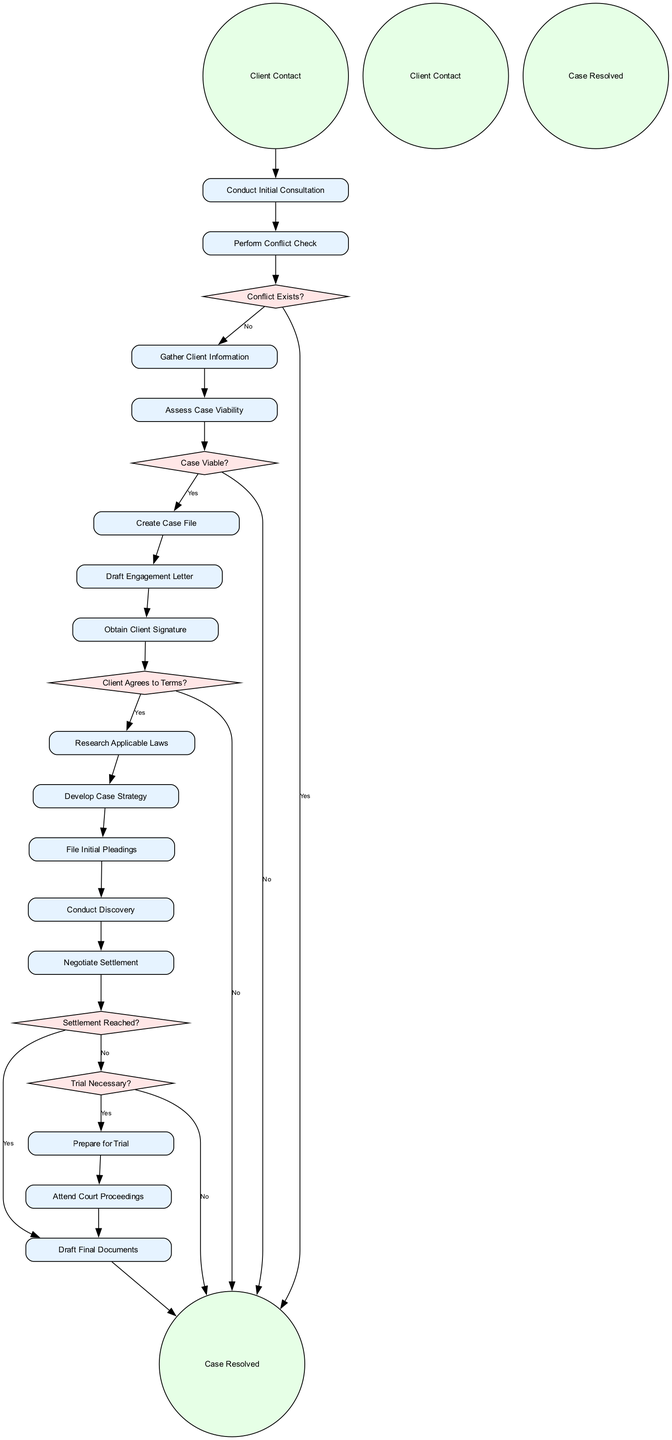What is the first activity in the process? The diagram starts with the initial node labeled "Client Contact," indicating this is the first step in the workflow.
Answer: Client Contact How many decision nodes are present in the diagram? The diagram includes five decision nodes: "Conflict Exists?", "Case Viable?", "Client Agrees to Terms?", "Settlement Reached?", and "Trial Necessary?". Counting these gives us a total of five decision nodes.
Answer: 5 What happens if a conflict exists? According to the diagram, if a conflict exists (labeled as "Yes" on the decision edge), the workflow leads directly to the "Case Resolved" node, indicating that the case cannot proceed.
Answer: Case Resolved Which activity follows the "Gather Client Information" step? After "Gather Client Information," the next activity in the flow is "Assess Case Viability," as indicated by the directed edge from "Gather Client Information" to "Assess Case Viability."
Answer: Assess Case Viability What is the result if the case is determined to be not viable? If the case is not viable (as indicated by the "No" edge from "Case Viable?"), the workflow proceeds to "Case Resolved," indicating that the case cannot continue.
Answer: Case Resolved If the client does not agree to the terms, what is the next step? If the client does not agree to the terms (as indicated by the "No" edge from "Client Agrees to Terms?"), the workflow leads directly to "Case Resolved," indicating the case cannot proceed further.
Answer: Case Resolved What is the final step in the workflow? The final node in the diagram is "Case Resolved," which represents the conclusion of the legal case management process, indicating that all activities have led to resolving the case.
Answer: Case Resolved Which activity comes before drafting final documents if a settlement is reached? If a settlement is reached (indicated by the "Yes" edge from "Settlement Reached?"), the preceding activity is "Draft Final Documents," which is the step taken just before the case is marked as resolved.
Answer: Draft Final Documents 